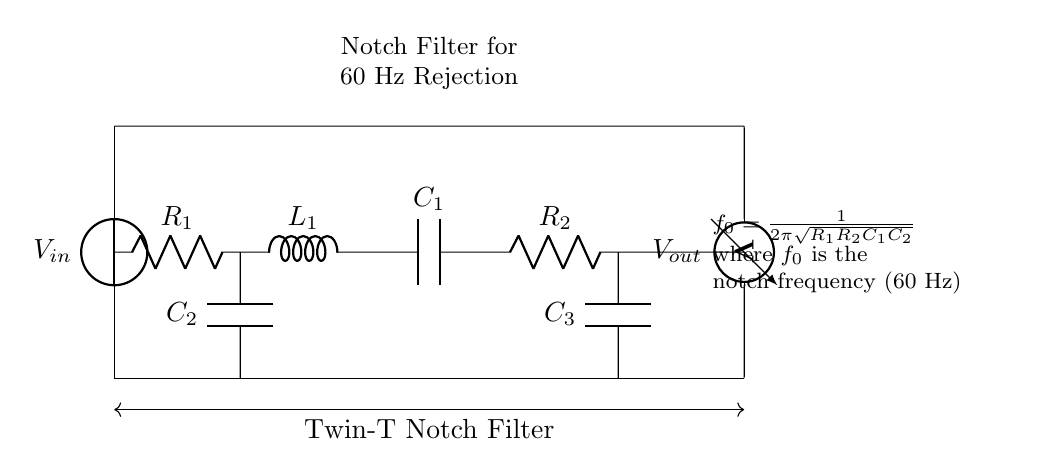What is the function of this circuit? The function of this circuit is to remove power line interference, specifically at the frequency of 60 Hz, which is common in electrical systems. This is achieved through its design as a notch filter.
Answer: Notch filter What are the main components in the circuit? The main components in the circuit include two resistors, three capacitors, and an inductor, specifically labeled as R1, R2, C1, C2, C3, and L1. These components work together to form the notch filter.
Answer: R1, R2, C1, C2, C3, L1 What is the notch frequency of this filter? The notch frequency, designated as f0, is calculated using the formula provided in the diagram. It is specifically set to remove the nominal power line frequency of 60 Hz.
Answer: 60 Hz How many capacitors are present in the circuit? There are three capacitors in the circuit, which are C1, C2, and C3. These capacitors are crucial for the operation of the notch filter.
Answer: Three What is the connection type of the resistors in the circuit? The resistors R1 and R2 are connected in series within the notch filter circuit. This means the current flows through each resistor one after the other, contributing to the overall impedance of the filter.
Answer: Series What does the voltage source represent? The voltage source, labeled as Vin, represents the input voltage applied to the circuit. It is essential for the operation of the notch filter, providing the necessary power for filtering out the interference.
Answer: Vin 